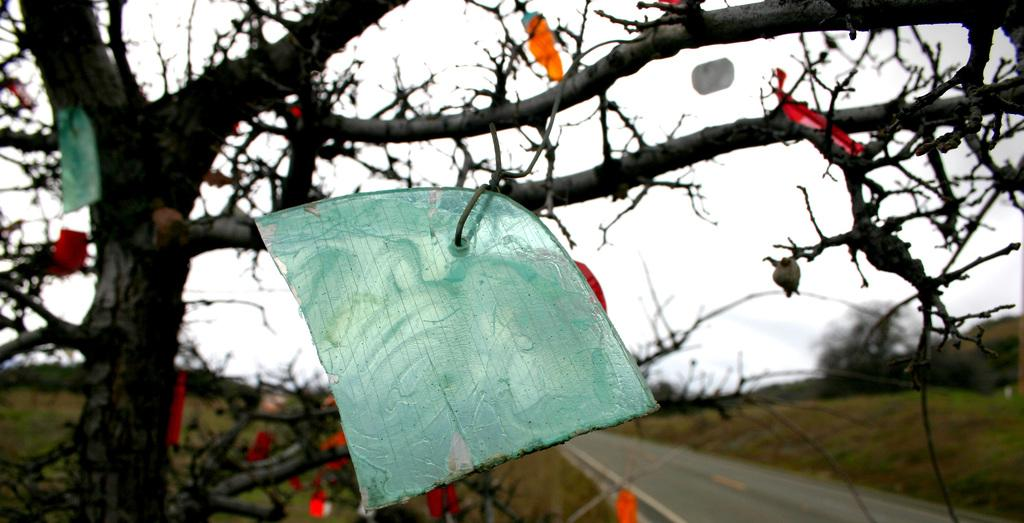What type of vegetation can be seen in the image? There are trees in the image. What type of man-made structure is present in the image? There is a road in the image. What is the condition of the sky in the image? The sky is clear in the image. How many horses can be seen pulling the lamp in the image? There are no horses or lamps present in the image. 